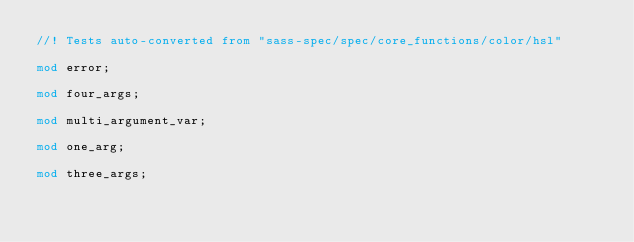<code> <loc_0><loc_0><loc_500><loc_500><_Rust_>//! Tests auto-converted from "sass-spec/spec/core_functions/color/hsl"

mod error;

mod four_args;

mod multi_argument_var;

mod one_arg;

mod three_args;
</code> 